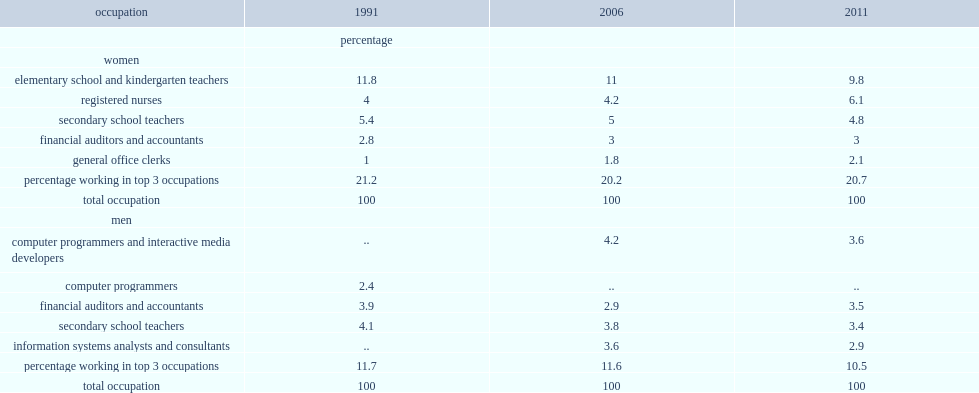What was the proportion of young females with a university degree that were elementary/kindergarten school teachers in 2011? 9.8. What was the proportion of young females with a university degree that were registered nurses in 2011? 6.1. What was the proportion of young females with a university degree that were seconday school teachers in 2011? 4.8. Which occupation had the largest proportion of young female workers with a university degree? Elementary school and kindergarten teachers. 